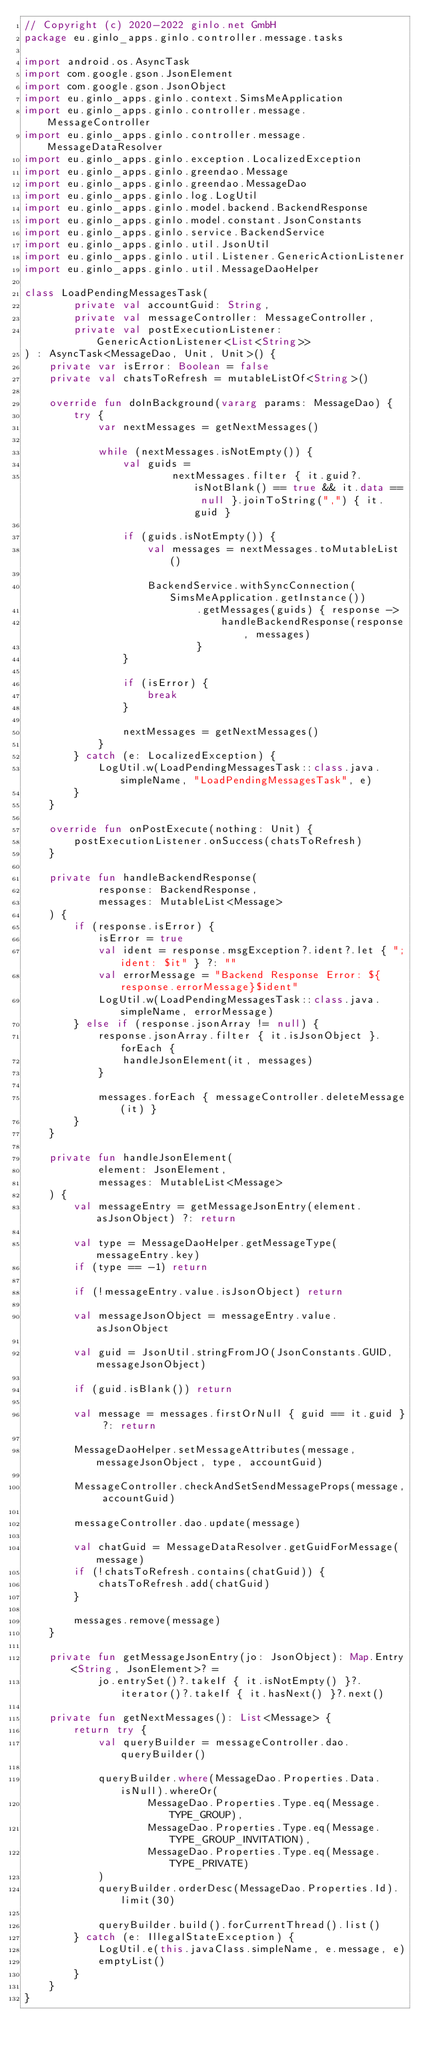Convert code to text. <code><loc_0><loc_0><loc_500><loc_500><_Kotlin_>// Copyright (c) 2020-2022 ginlo.net GmbH
package eu.ginlo_apps.ginlo.controller.message.tasks

import android.os.AsyncTask
import com.google.gson.JsonElement
import com.google.gson.JsonObject
import eu.ginlo_apps.ginlo.context.SimsMeApplication
import eu.ginlo_apps.ginlo.controller.message.MessageController
import eu.ginlo_apps.ginlo.controller.message.MessageDataResolver
import eu.ginlo_apps.ginlo.exception.LocalizedException
import eu.ginlo_apps.ginlo.greendao.Message
import eu.ginlo_apps.ginlo.greendao.MessageDao
import eu.ginlo_apps.ginlo.log.LogUtil
import eu.ginlo_apps.ginlo.model.backend.BackendResponse
import eu.ginlo_apps.ginlo.model.constant.JsonConstants
import eu.ginlo_apps.ginlo.service.BackendService
import eu.ginlo_apps.ginlo.util.JsonUtil
import eu.ginlo_apps.ginlo.util.Listener.GenericActionListener
import eu.ginlo_apps.ginlo.util.MessageDaoHelper

class LoadPendingMessagesTask(
        private val accountGuid: String,
        private val messageController: MessageController,
        private val postExecutionListener: GenericActionListener<List<String>>
) : AsyncTask<MessageDao, Unit, Unit>() {
    private var isError: Boolean = false
    private val chatsToRefresh = mutableListOf<String>()

    override fun doInBackground(vararg params: MessageDao) {
        try {
            var nextMessages = getNextMessages()

            while (nextMessages.isNotEmpty()) {
                val guids =
                        nextMessages.filter { it.guid?.isNotBlank() == true && it.data == null }.joinToString(",") { it.guid }

                if (guids.isNotEmpty()) {
                    val messages = nextMessages.toMutableList()

                    BackendService.withSyncConnection(SimsMeApplication.getInstance())
                            .getMessages(guids) { response ->
                                handleBackendResponse(response, messages)
                            }
                }

                if (isError) {
                    break
                }

                nextMessages = getNextMessages()
            }
        } catch (e: LocalizedException) {
            LogUtil.w(LoadPendingMessagesTask::class.java.simpleName, "LoadPendingMessagesTask", e)
        }
    }

    override fun onPostExecute(nothing: Unit) {
        postExecutionListener.onSuccess(chatsToRefresh)
    }

    private fun handleBackendResponse(
            response: BackendResponse,
            messages: MutableList<Message>
    ) {
        if (response.isError) {
            isError = true
            val ident = response.msgException?.ident?.let { ";ident: $it" } ?: ""
            val errorMessage = "Backend Response Error: ${response.errorMessage}$ident"
            LogUtil.w(LoadPendingMessagesTask::class.java.simpleName, errorMessage)
        } else if (response.jsonArray != null) {
            response.jsonArray.filter { it.isJsonObject }.forEach {
                handleJsonElement(it, messages)
            }

            messages.forEach { messageController.deleteMessage(it) }
        }
    }

    private fun handleJsonElement(
            element: JsonElement,
            messages: MutableList<Message>
    ) {
        val messageEntry = getMessageJsonEntry(element.asJsonObject) ?: return

        val type = MessageDaoHelper.getMessageType(messageEntry.key)
        if (type == -1) return

        if (!messageEntry.value.isJsonObject) return

        val messageJsonObject = messageEntry.value.asJsonObject

        val guid = JsonUtil.stringFromJO(JsonConstants.GUID, messageJsonObject)

        if (guid.isBlank()) return

        val message = messages.firstOrNull { guid == it.guid } ?: return

        MessageDaoHelper.setMessageAttributes(message, messageJsonObject, type, accountGuid)

        MessageController.checkAndSetSendMessageProps(message, accountGuid)

        messageController.dao.update(message)

        val chatGuid = MessageDataResolver.getGuidForMessage(message)
        if (!chatsToRefresh.contains(chatGuid)) {
            chatsToRefresh.add(chatGuid)
        }

        messages.remove(message)
    }

    private fun getMessageJsonEntry(jo: JsonObject): Map.Entry<String, JsonElement>? =
            jo.entrySet()?.takeIf { it.isNotEmpty() }?.iterator()?.takeIf { it.hasNext() }?.next()

    private fun getNextMessages(): List<Message> {
        return try {
            val queryBuilder = messageController.dao.queryBuilder()

            queryBuilder.where(MessageDao.Properties.Data.isNull).whereOr(
                    MessageDao.Properties.Type.eq(Message.TYPE_GROUP),
                    MessageDao.Properties.Type.eq(Message.TYPE_GROUP_INVITATION),
                    MessageDao.Properties.Type.eq(Message.TYPE_PRIVATE)
            )
            queryBuilder.orderDesc(MessageDao.Properties.Id).limit(30)

            queryBuilder.build().forCurrentThread().list()
        } catch (e: IllegalStateException) {
            LogUtil.e(this.javaClass.simpleName, e.message, e)
            emptyList()
        }
    }
}
</code> 